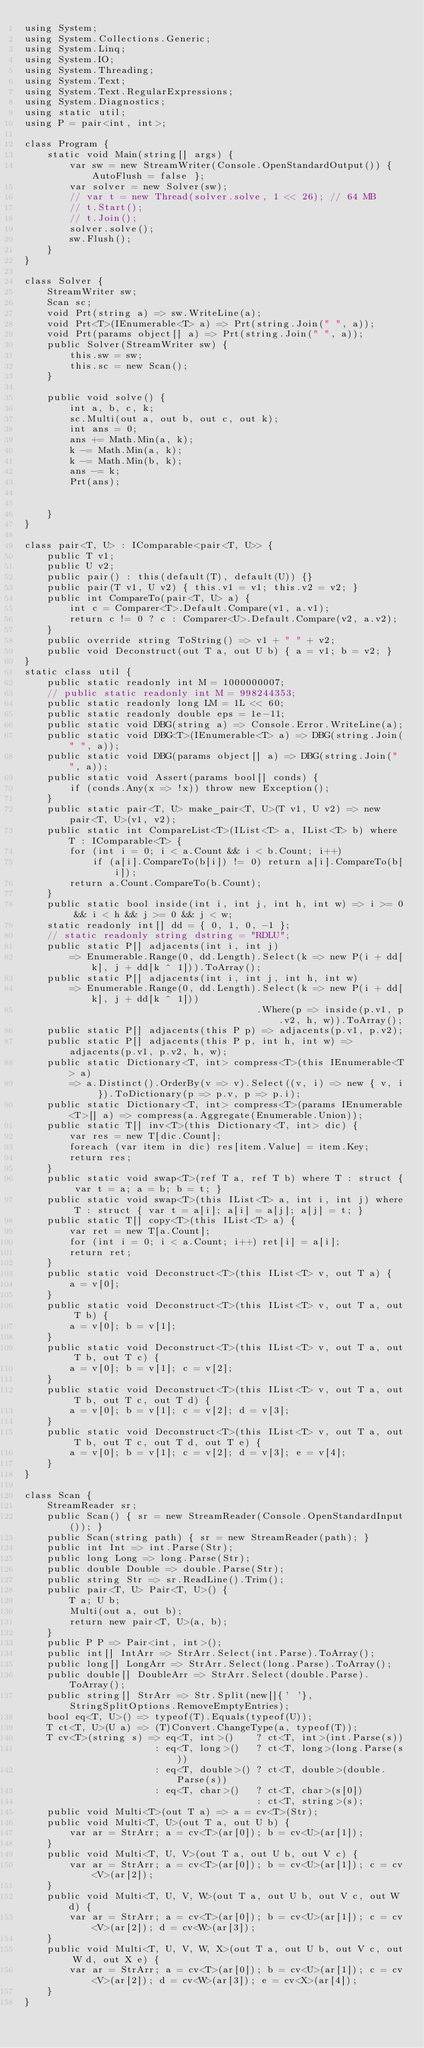Convert code to text. <code><loc_0><loc_0><loc_500><loc_500><_C#_>using System;
using System.Collections.Generic;
using System.Linq;
using System.IO;
using System.Threading;
using System.Text;
using System.Text.RegularExpressions;
using System.Diagnostics;
using static util;
using P = pair<int, int>;

class Program {
    static void Main(string[] args) {
        var sw = new StreamWriter(Console.OpenStandardOutput()) { AutoFlush = false };
        var solver = new Solver(sw);
        // var t = new Thread(solver.solve, 1 << 26); // 64 MB
        // t.Start();
        // t.Join();
        solver.solve();
        sw.Flush();
    }
}

class Solver {
    StreamWriter sw;
    Scan sc;
    void Prt(string a) => sw.WriteLine(a);
    void Prt<T>(IEnumerable<T> a) => Prt(string.Join(" ", a));
    void Prt(params object[] a) => Prt(string.Join(" ", a));
    public Solver(StreamWriter sw) {
        this.sw = sw;
        this.sc = new Scan();
    }

    public void solve() {
        int a, b, c, k;
        sc.Multi(out a, out b, out c, out k);
        int ans = 0;
        ans += Math.Min(a, k);
        k -= Math.Min(a, k);
        k -= Math.Min(b, k);
        ans -= k;
        Prt(ans);


    }
}

class pair<T, U> : IComparable<pair<T, U>> {
    public T v1;
    public U v2;
    public pair() : this(default(T), default(U)) {}
    public pair(T v1, U v2) { this.v1 = v1; this.v2 = v2; }
    public int CompareTo(pair<T, U> a) {
        int c = Comparer<T>.Default.Compare(v1, a.v1);
        return c != 0 ? c : Comparer<U>.Default.Compare(v2, a.v2);
    }
    public override string ToString() => v1 + " " + v2;
    public void Deconstruct(out T a, out U b) { a = v1; b = v2; }
}
static class util {
    public static readonly int M = 1000000007;
    // public static readonly int M = 998244353;
    public static readonly long LM = 1L << 60;
    public static readonly double eps = 1e-11;
    public static void DBG(string a) => Console.Error.WriteLine(a);
    public static void DBG<T>(IEnumerable<T> a) => DBG(string.Join(" ", a));
    public static void DBG(params object[] a) => DBG(string.Join(" ", a));
    public static void Assert(params bool[] conds) {
        if (conds.Any(x => !x)) throw new Exception();
    }
    public static pair<T, U> make_pair<T, U>(T v1, U v2) => new pair<T, U>(v1, v2);
    public static int CompareList<T>(IList<T> a, IList<T> b) where T : IComparable<T> {
        for (int i = 0; i < a.Count && i < b.Count; i++)
            if (a[i].CompareTo(b[i]) != 0) return a[i].CompareTo(b[i]);
        return a.Count.CompareTo(b.Count);
    }
    public static bool inside(int i, int j, int h, int w) => i >= 0 && i < h && j >= 0 && j < w;
    static readonly int[] dd = { 0, 1, 0, -1 };
    // static readonly string dstring = "RDLU";
    public static P[] adjacents(int i, int j)
        => Enumerable.Range(0, dd.Length).Select(k => new P(i + dd[k], j + dd[k ^ 1])).ToArray();
    public static P[] adjacents(int i, int j, int h, int w)
        => Enumerable.Range(0, dd.Length).Select(k => new P(i + dd[k], j + dd[k ^ 1]))
                                         .Where(p => inside(p.v1, p.v2, h, w)).ToArray();
    public static P[] adjacents(this P p) => adjacents(p.v1, p.v2);
    public static P[] adjacents(this P p, int h, int w) => adjacents(p.v1, p.v2, h, w);
    public static Dictionary<T, int> compress<T>(this IEnumerable<T> a)
        => a.Distinct().OrderBy(v => v).Select((v, i) => new { v, i }).ToDictionary(p => p.v, p => p.i);
    public static Dictionary<T, int> compress<T>(params IEnumerable<T>[] a) => compress(a.Aggregate(Enumerable.Union));
    public static T[] inv<T>(this Dictionary<T, int> dic) {
        var res = new T[dic.Count];
        foreach (var item in dic) res[item.Value] = item.Key;
        return res;
    }
    public static void swap<T>(ref T a, ref T b) where T : struct { var t = a; a = b; b = t; }
    public static void swap<T>(this IList<T> a, int i, int j) where T : struct { var t = a[i]; a[i] = a[j]; a[j] = t; }
    public static T[] copy<T>(this IList<T> a) {
        var ret = new T[a.Count];
        for (int i = 0; i < a.Count; i++) ret[i] = a[i];
        return ret;
    }
    public static void Deconstruct<T>(this IList<T> v, out T a) {
        a = v[0];
    }
    public static void Deconstruct<T>(this IList<T> v, out T a, out T b) {
        a = v[0]; b = v[1];
    }
    public static void Deconstruct<T>(this IList<T> v, out T a, out T b, out T c) {
        a = v[0]; b = v[1]; c = v[2];
    }
    public static void Deconstruct<T>(this IList<T> v, out T a, out T b, out T c, out T d) {
        a = v[0]; b = v[1]; c = v[2]; d = v[3];
    }
    public static void Deconstruct<T>(this IList<T> v, out T a, out T b, out T c, out T d, out T e) {
        a = v[0]; b = v[1]; c = v[2]; d = v[3]; e = v[4];
    }
}

class Scan {
    StreamReader sr;
    public Scan() { sr = new StreamReader(Console.OpenStandardInput()); }
    public Scan(string path) { sr = new StreamReader(path); }
    public int Int => int.Parse(Str);
    public long Long => long.Parse(Str);
    public double Double => double.Parse(Str);
    public string Str => sr.ReadLine().Trim();
    public pair<T, U> Pair<T, U>() {
        T a; U b;
        Multi(out a, out b);
        return new pair<T, U>(a, b);
    }
    public P P => Pair<int, int>();
    public int[] IntArr => StrArr.Select(int.Parse).ToArray();
    public long[] LongArr => StrArr.Select(long.Parse).ToArray();
    public double[] DoubleArr => StrArr.Select(double.Parse).ToArray();
    public string[] StrArr => Str.Split(new[]{' '}, StringSplitOptions.RemoveEmptyEntries);
    bool eq<T, U>() => typeof(T).Equals(typeof(U));
    T ct<T, U>(U a) => (T)Convert.ChangeType(a, typeof(T));
    T cv<T>(string s) => eq<T, int>()    ? ct<T, int>(int.Parse(s))
                       : eq<T, long>()   ? ct<T, long>(long.Parse(s))
                       : eq<T, double>() ? ct<T, double>(double.Parse(s))
                       : eq<T, char>()   ? ct<T, char>(s[0])
                                         : ct<T, string>(s);
    public void Multi<T>(out T a) => a = cv<T>(Str);
    public void Multi<T, U>(out T a, out U b) {
        var ar = StrArr; a = cv<T>(ar[0]); b = cv<U>(ar[1]);
    }
    public void Multi<T, U, V>(out T a, out U b, out V c) {
        var ar = StrArr; a = cv<T>(ar[0]); b = cv<U>(ar[1]); c = cv<V>(ar[2]);
    }
    public void Multi<T, U, V, W>(out T a, out U b, out V c, out W d) {
        var ar = StrArr; a = cv<T>(ar[0]); b = cv<U>(ar[1]); c = cv<V>(ar[2]); d = cv<W>(ar[3]);
    }
    public void Multi<T, U, V, W, X>(out T a, out U b, out V c, out W d, out X e) {
        var ar = StrArr; a = cv<T>(ar[0]); b = cv<U>(ar[1]); c = cv<V>(ar[2]); d = cv<W>(ar[3]); e = cv<X>(ar[4]);
    }
}
</code> 